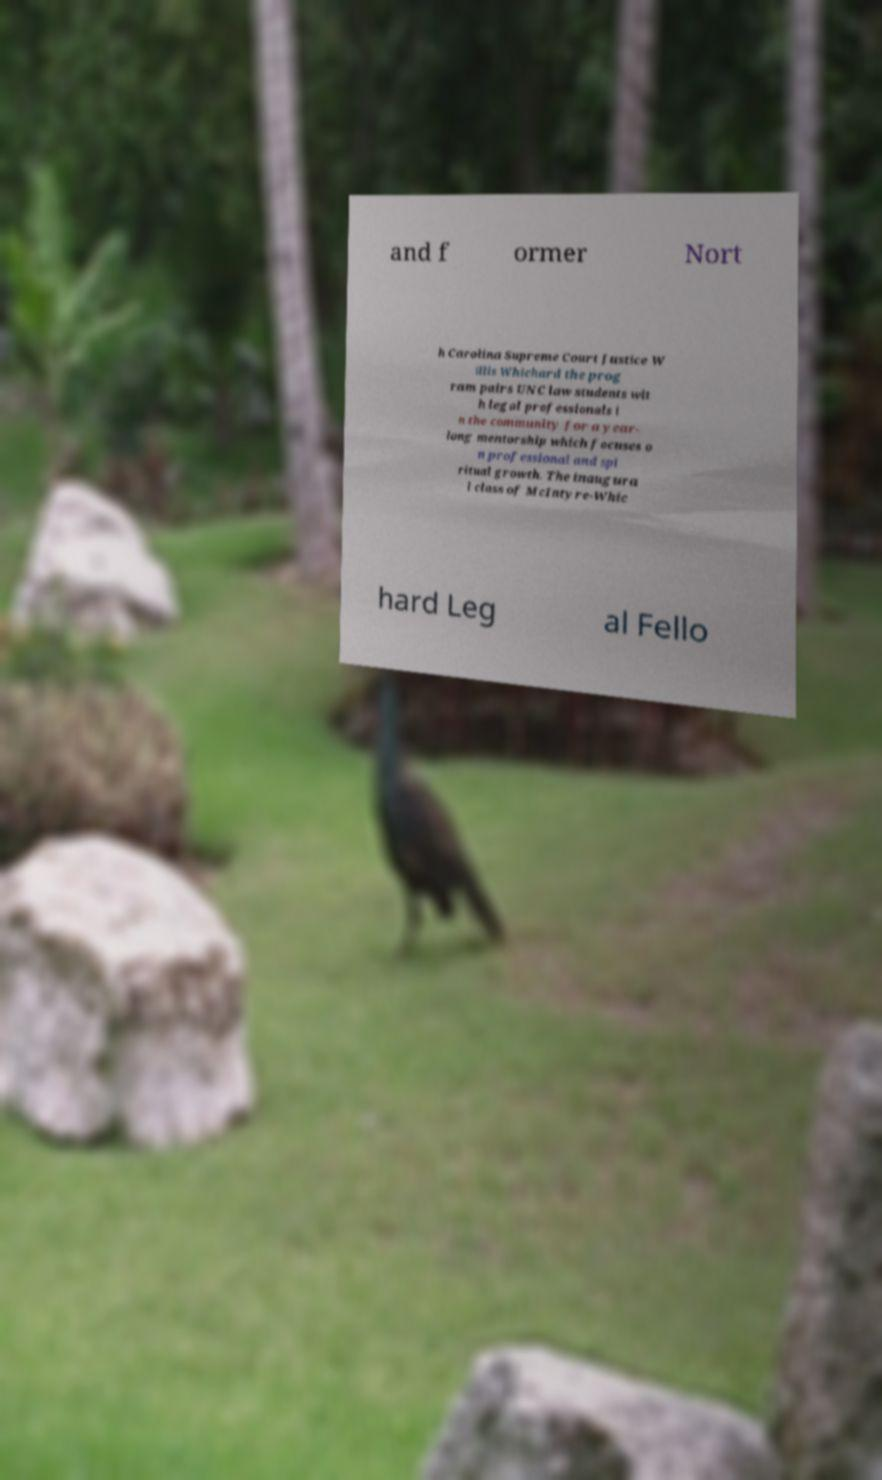For documentation purposes, I need the text within this image transcribed. Could you provide that? and f ormer Nort h Carolina Supreme Court Justice W illis Whichard the prog ram pairs UNC law students wit h legal professionals i n the community for a year- long mentorship which focuses o n professional and spi ritual growth. The inaugura l class of McIntyre-Whic hard Leg al Fello 